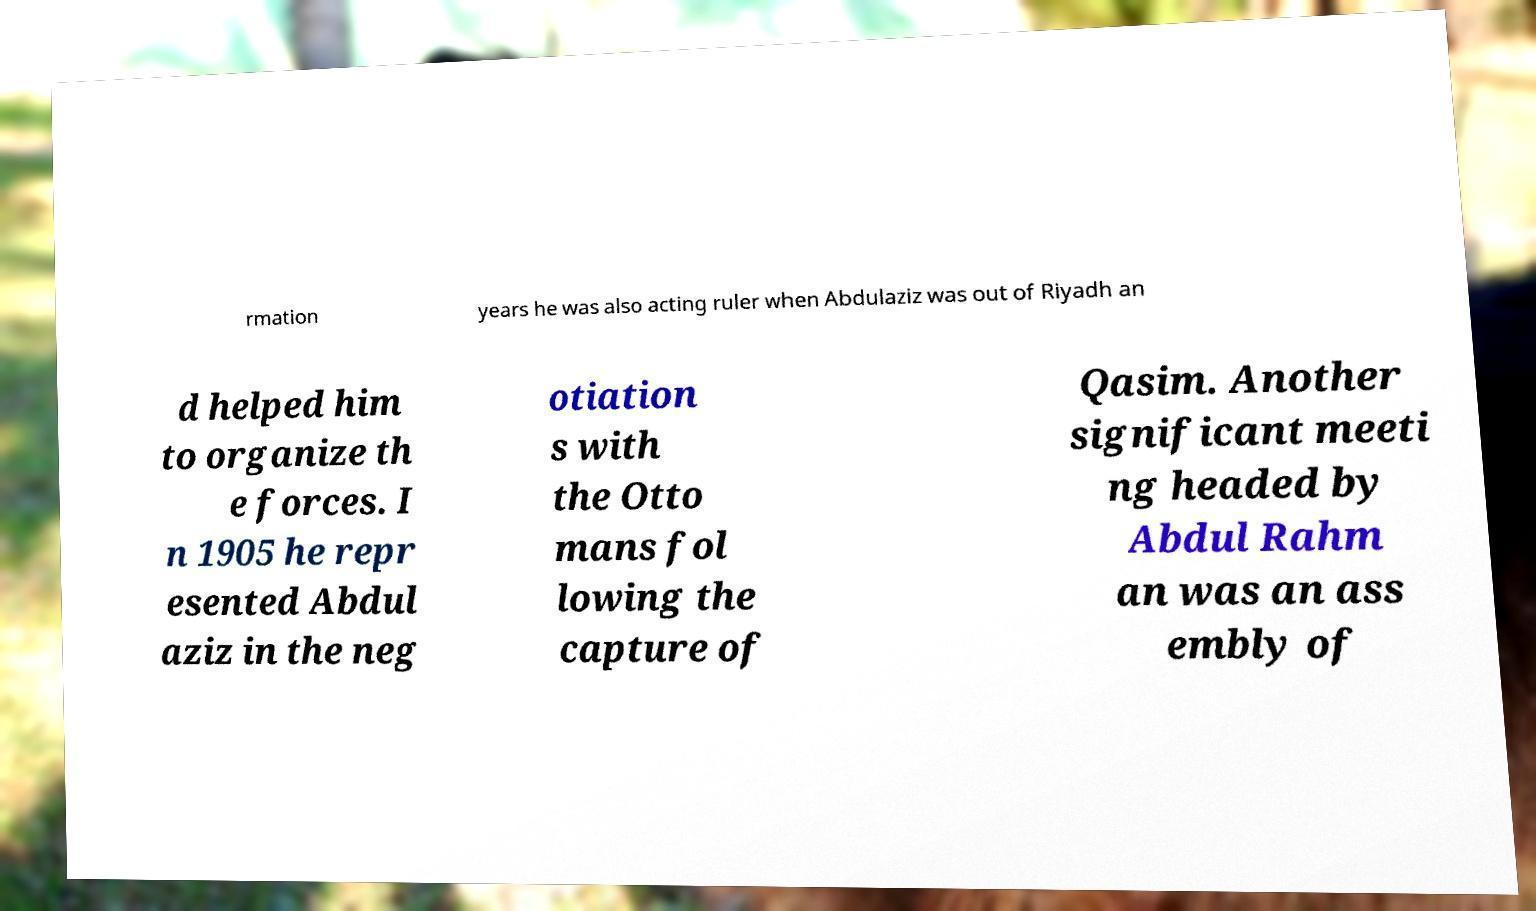What messages or text are displayed in this image? I need them in a readable, typed format. rmation years he was also acting ruler when Abdulaziz was out of Riyadh an d helped him to organize th e forces. I n 1905 he repr esented Abdul aziz in the neg otiation s with the Otto mans fol lowing the capture of Qasim. Another significant meeti ng headed by Abdul Rahm an was an ass embly of 